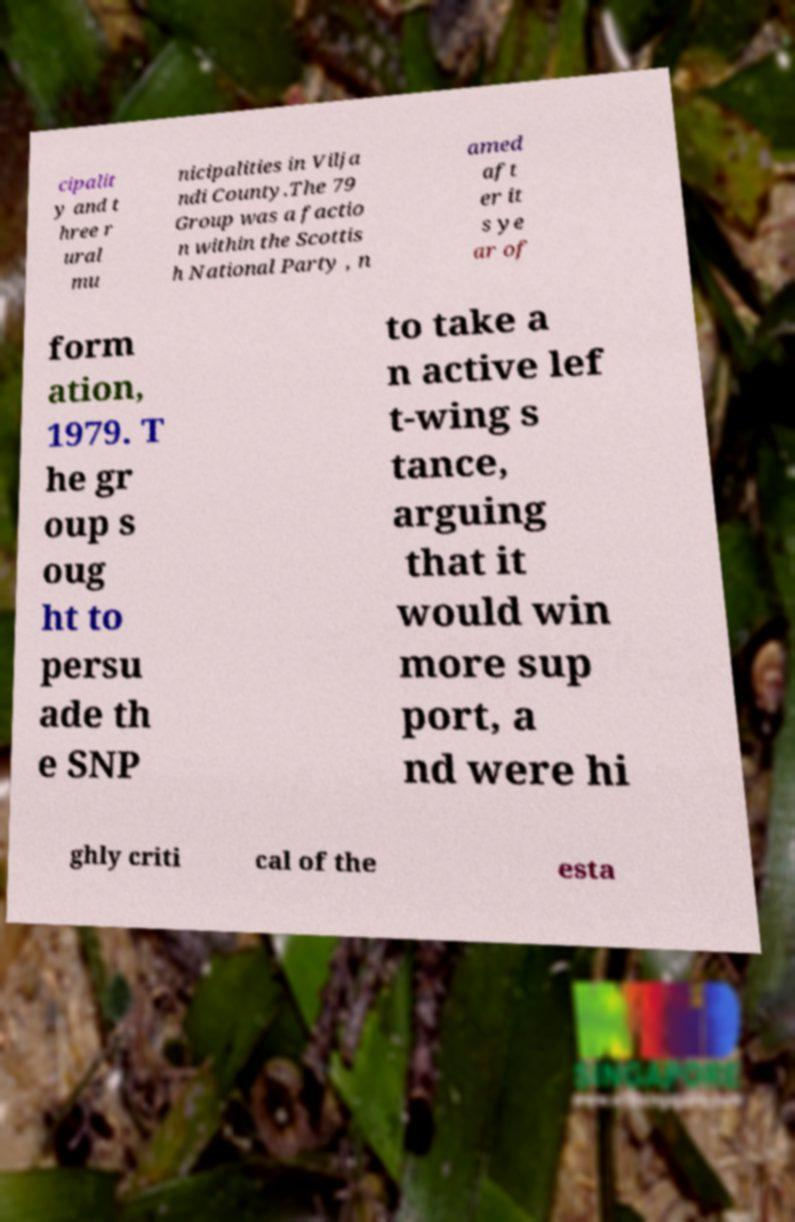I need the written content from this picture converted into text. Can you do that? cipalit y and t hree r ural mu nicipalities in Vilja ndi County.The 79 Group was a factio n within the Scottis h National Party , n amed aft er it s ye ar of form ation, 1979. T he gr oup s oug ht to persu ade th e SNP to take a n active lef t-wing s tance, arguing that it would win more sup port, a nd were hi ghly criti cal of the esta 